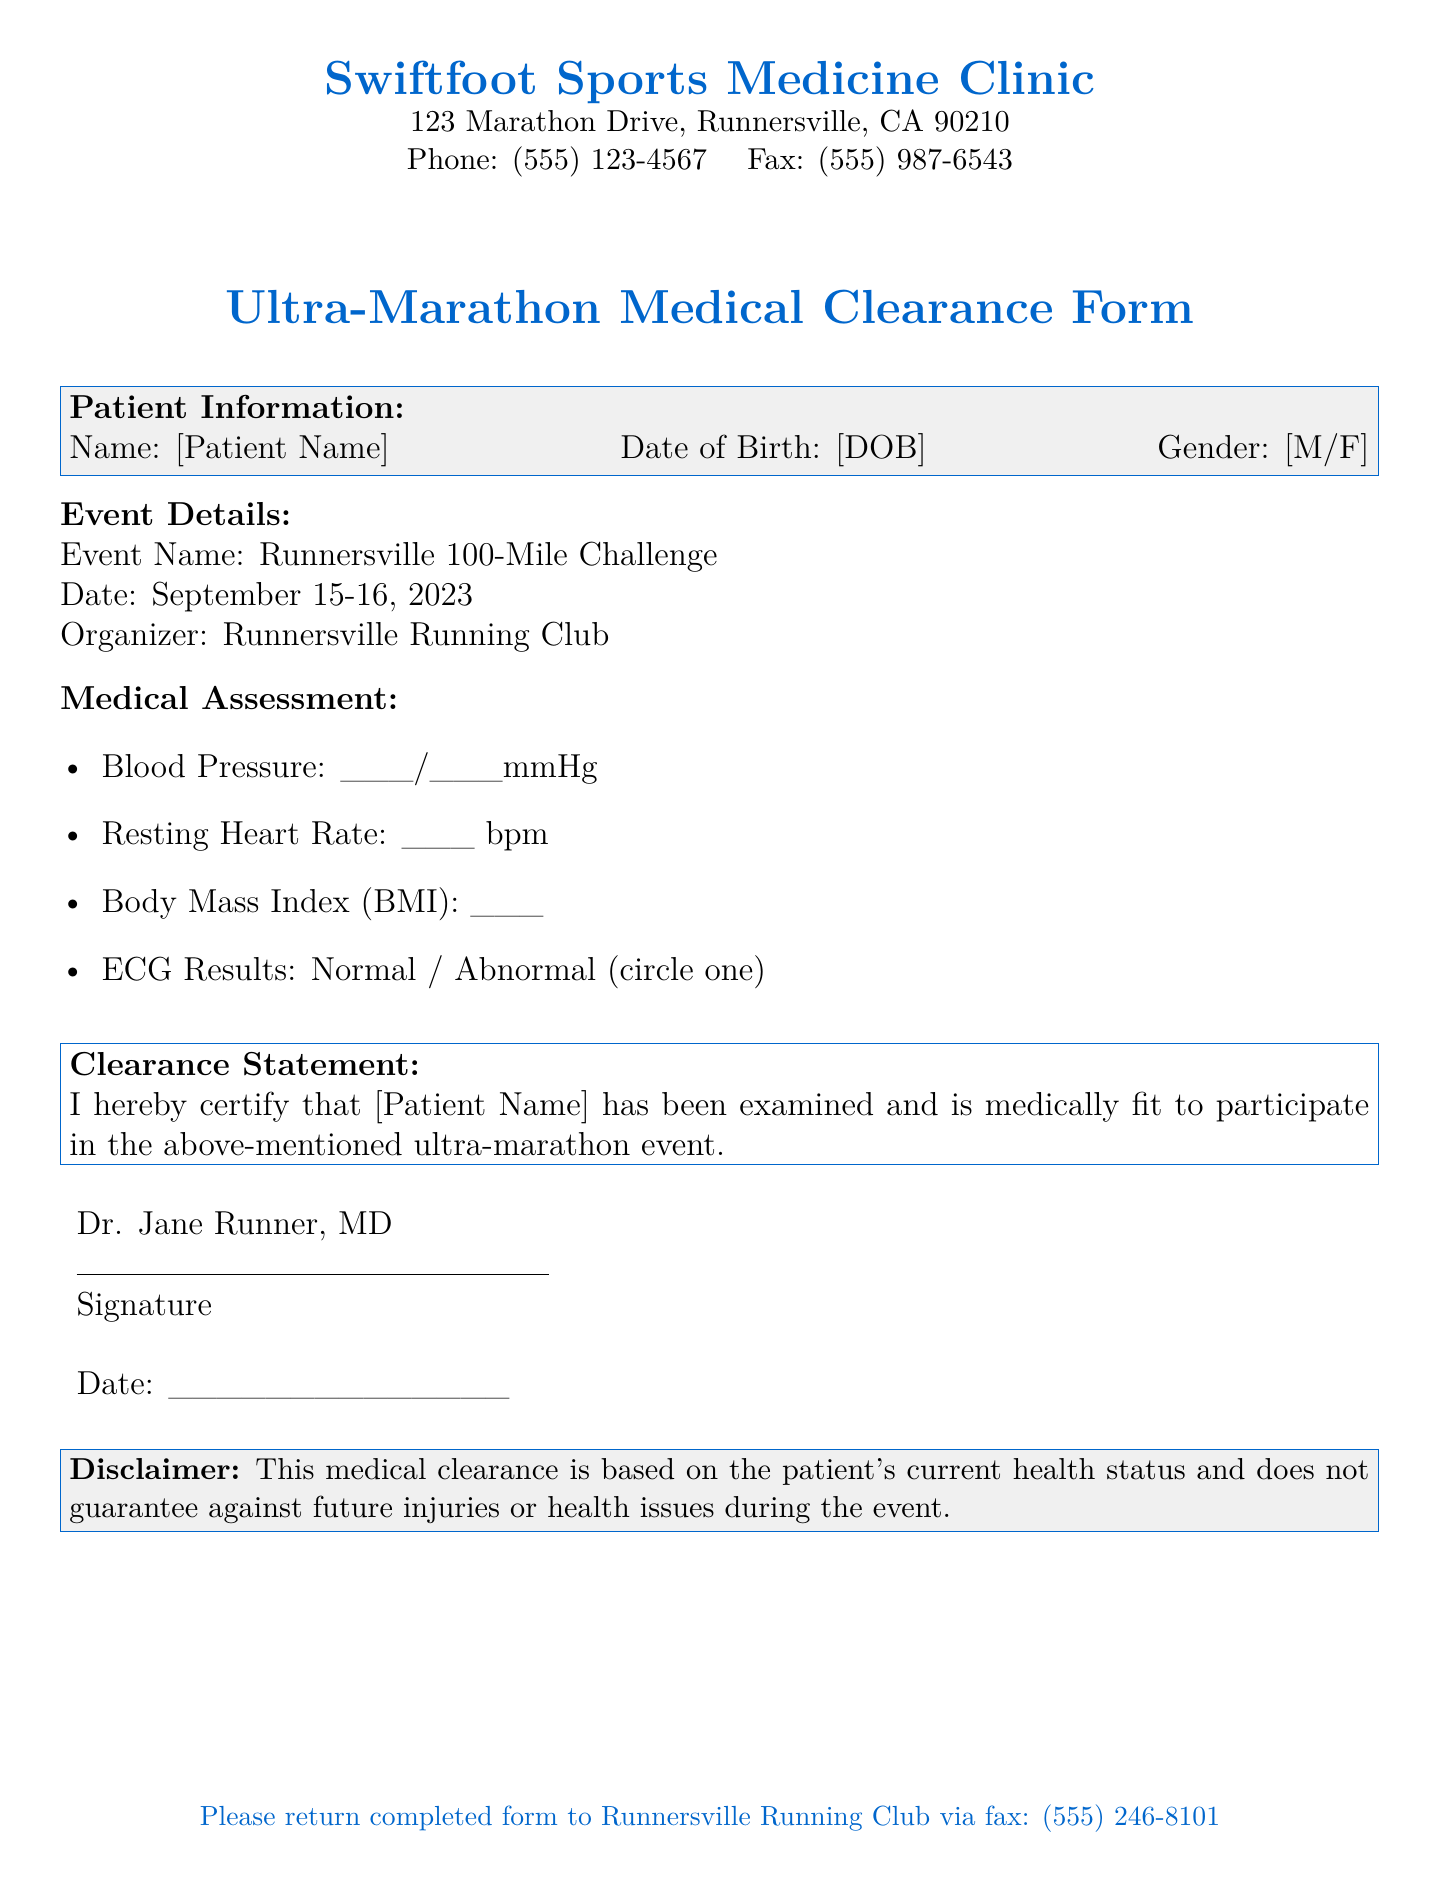What is the name of the clinic? The name of the clinic is mentioned at the top of the document.
Answer: Swiftfoot Sports Medicine Clinic What is the event name? The event name is specified under the event details section.
Answer: Runnersville 100-Mile Challenge What is the date of the ultra-marathon event? The date is listed in the event details section of the document.
Answer: September 15-16, 2023 Who signed the medical clearance form? The doctor's name is found at the bottom of the clearance statement.
Answer: Dr. Jane Runner What information is required for the blood pressure? The document requests a specific format for blood pressure measurements.
Answer: ___/___mmHg What is the disclaimer concerning the medical clearance? The disclaimer warns about future injuries or health issues.
Answer: Current health status Why might participants need to return the form? The form is required for participation in the ultra-marathon event as indicated.
Answer: For participation What must be circled in the medical assessment? The section indicates that one option needs to be selected regarding ECG results.
Answer: Normal / Abnormal What action is requested at the bottom of the document? The document requests a specific action regarding the completed form.
Answer: Return completed form 